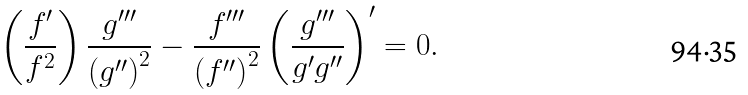<formula> <loc_0><loc_0><loc_500><loc_500>\left ( \frac { f ^ { \prime } } { f ^ { 2 } } \right ) \frac { g ^ { \prime \prime \prime } } { \left ( g ^ { \prime \prime } \right ) ^ { 2 } } - \frac { f ^ { \prime \prime \prime } } { \left ( f ^ { \prime \prime } \right ) ^ { 2 } } \left ( \frac { g ^ { \prime \prime \prime } } { g ^ { \prime } g ^ { \prime \prime } } \right ) ^ { \prime } = 0 .</formula> 